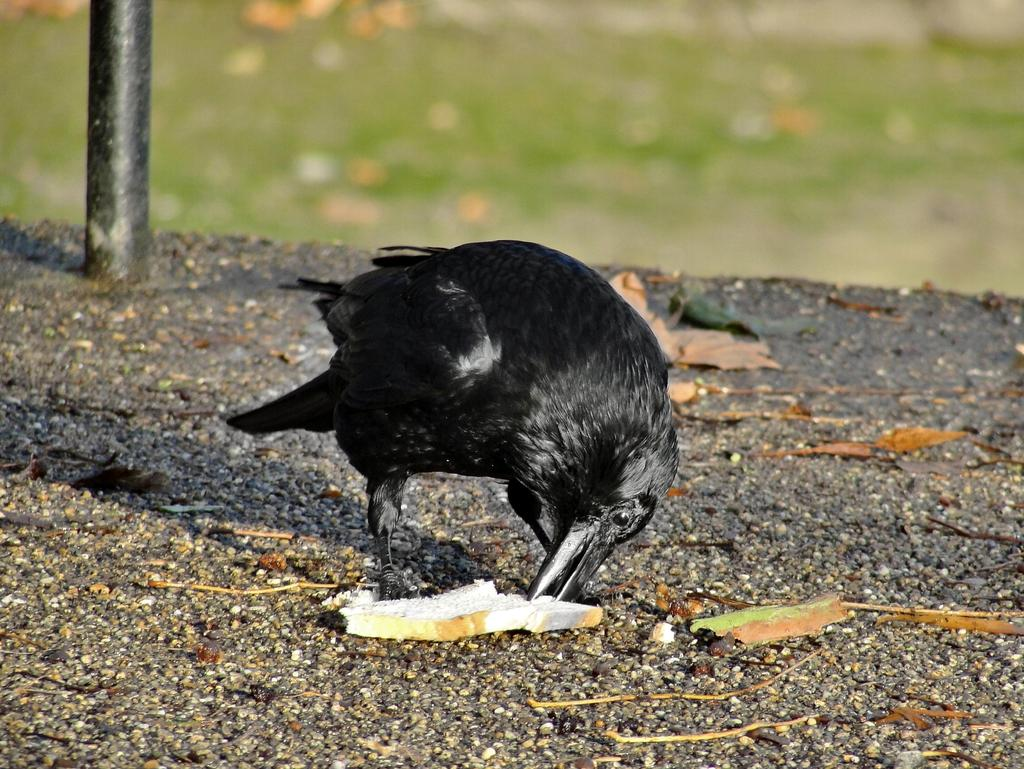What type of animal is in the image? There is a bird in the image. What else can be seen in the image besides the bird? There is a pole in the image. Can you describe the background of the image? The background of the image is blurred. How many dogs are participating in the joke in the image? There are no dogs or jokes present in the image; it features a bird and a pole with a blurred background. 